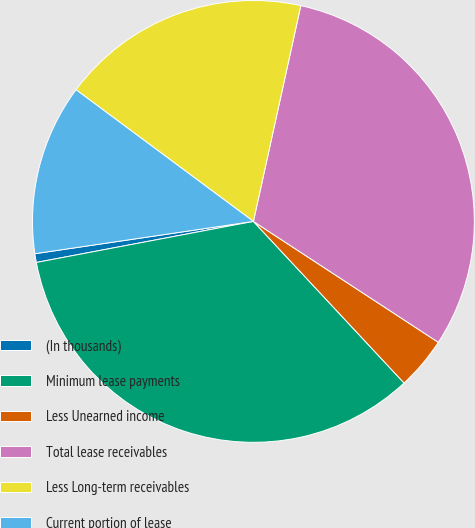<chart> <loc_0><loc_0><loc_500><loc_500><pie_chart><fcel>(In thousands)<fcel>Minimum lease payments<fcel>Less Unearned income<fcel>Total lease receivables<fcel>Less Long-term receivables<fcel>Current portion of lease<nl><fcel>0.64%<fcel>33.97%<fcel>3.84%<fcel>30.78%<fcel>18.28%<fcel>12.5%<nl></chart> 